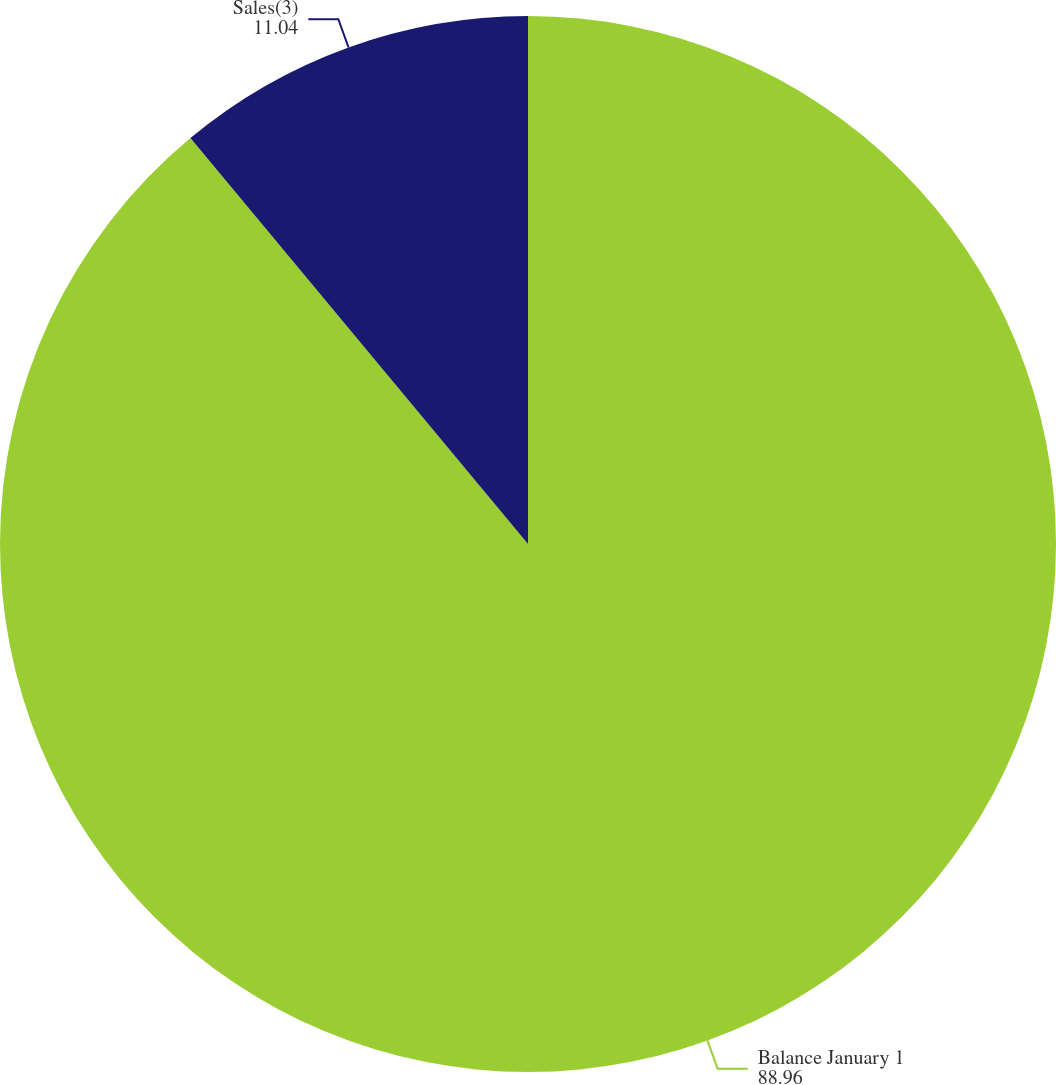Convert chart. <chart><loc_0><loc_0><loc_500><loc_500><pie_chart><fcel>Balance January 1<fcel>Sales(3)<nl><fcel>88.96%<fcel>11.04%<nl></chart> 